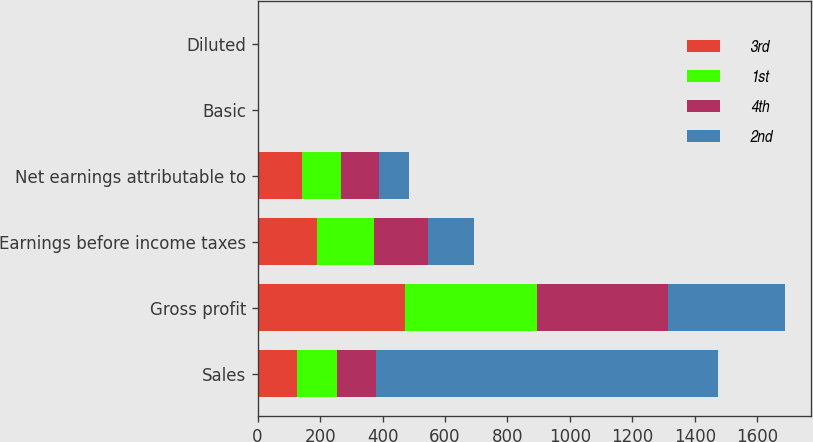<chart> <loc_0><loc_0><loc_500><loc_500><stacked_bar_chart><ecel><fcel>Sales<fcel>Gross profit<fcel>Earnings before income taxes<fcel>Net earnings attributable to<fcel>Basic<fcel>Diluted<nl><fcel>3rd<fcel>126.3<fcel>470.5<fcel>191.7<fcel>141.1<fcel>1.01<fcel>1.01<nl><fcel>1st<fcel>126.3<fcel>422.7<fcel>182.4<fcel>126.3<fcel>0.9<fcel>0.9<nl><fcel>4th<fcel>126.3<fcel>421.6<fcel>171.3<fcel>120.4<fcel>0.85<fcel>0.84<nl><fcel>2nd<fcel>1096.6<fcel>373.3<fcel>147.6<fcel>97.8<fcel>0.68<fcel>0.67<nl></chart> 